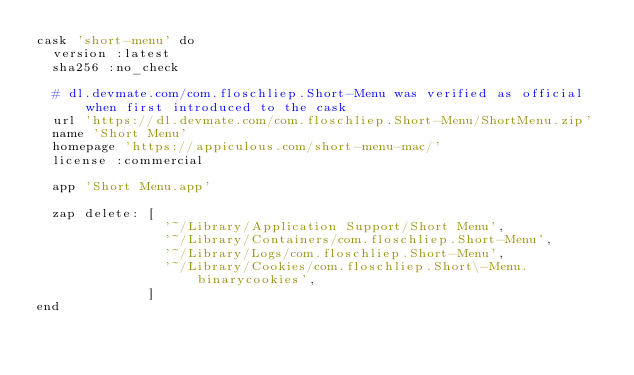<code> <loc_0><loc_0><loc_500><loc_500><_Ruby_>cask 'short-menu' do
  version :latest
  sha256 :no_check

  # dl.devmate.com/com.floschliep.Short-Menu was verified as official when first introduced to the cask
  url 'https://dl.devmate.com/com.floschliep.Short-Menu/ShortMenu.zip'
  name 'Short Menu'
  homepage 'https://appiculous.com/short-menu-mac/'
  license :commercial

  app 'Short Menu.app'

  zap delete: [
                '~/Library/Application Support/Short Menu',
                '~/Library/Containers/com.floschliep.Short-Menu',
                '~/Library/Logs/com.floschliep.Short-Menu',
                '~/Library/Cookies/com.floschliep.Short\-Menu.binarycookies',
              ]
end
</code> 